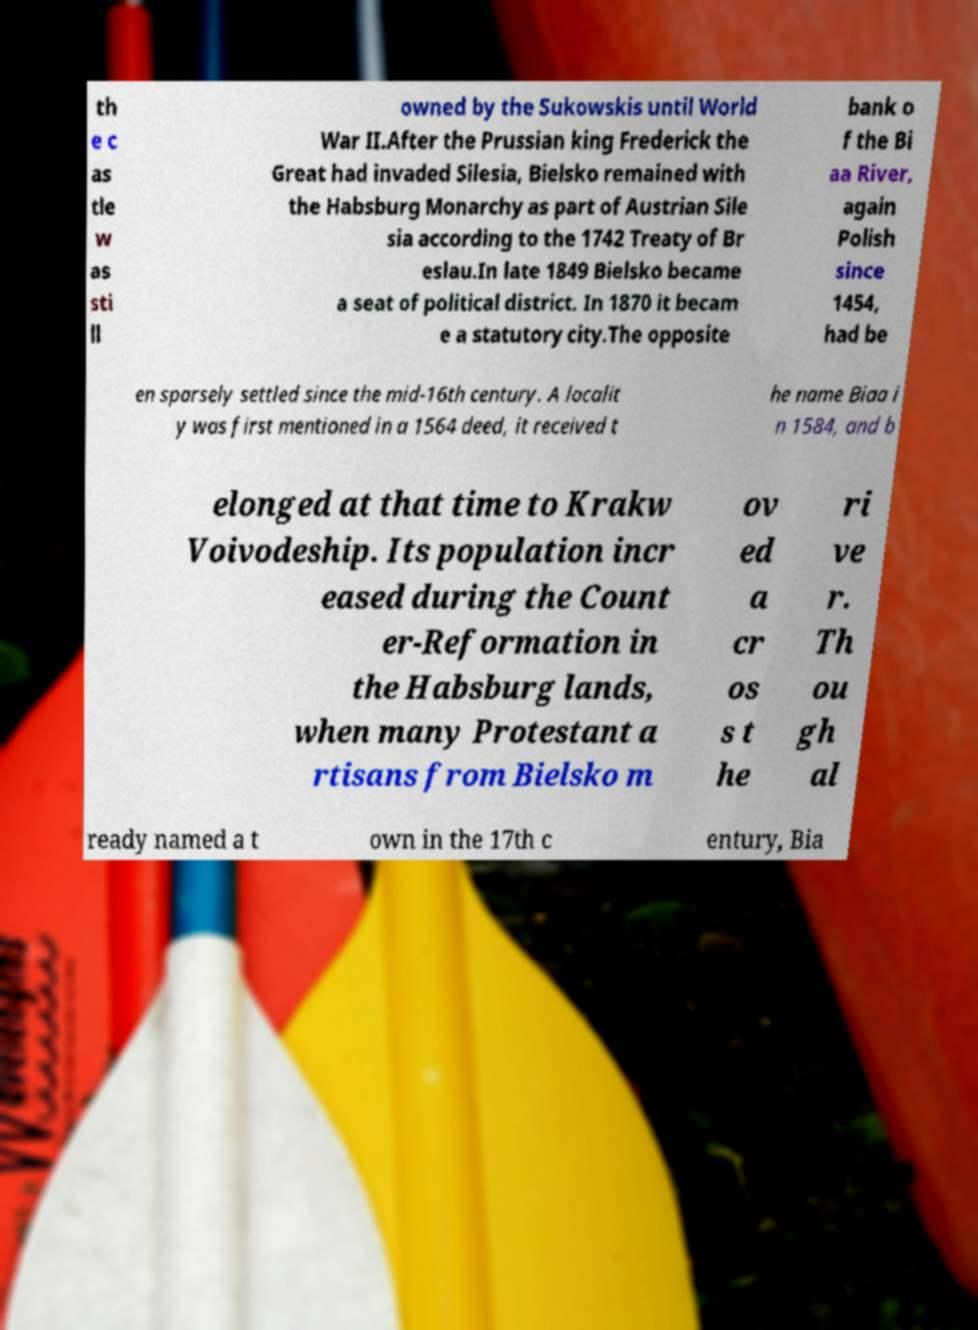I need the written content from this picture converted into text. Can you do that? th e c as tle w as sti ll owned by the Sukowskis until World War II.After the Prussian king Frederick the Great had invaded Silesia, Bielsko remained with the Habsburg Monarchy as part of Austrian Sile sia according to the 1742 Treaty of Br eslau.In late 1849 Bielsko became a seat of political district. In 1870 it becam e a statutory city.The opposite bank o f the Bi aa River, again Polish since 1454, had be en sparsely settled since the mid-16th century. A localit y was first mentioned in a 1564 deed, it received t he name Biaa i n 1584, and b elonged at that time to Krakw Voivodeship. Its population incr eased during the Count er-Reformation in the Habsburg lands, when many Protestant a rtisans from Bielsko m ov ed a cr os s t he ri ve r. Th ou gh al ready named a t own in the 17th c entury, Bia 